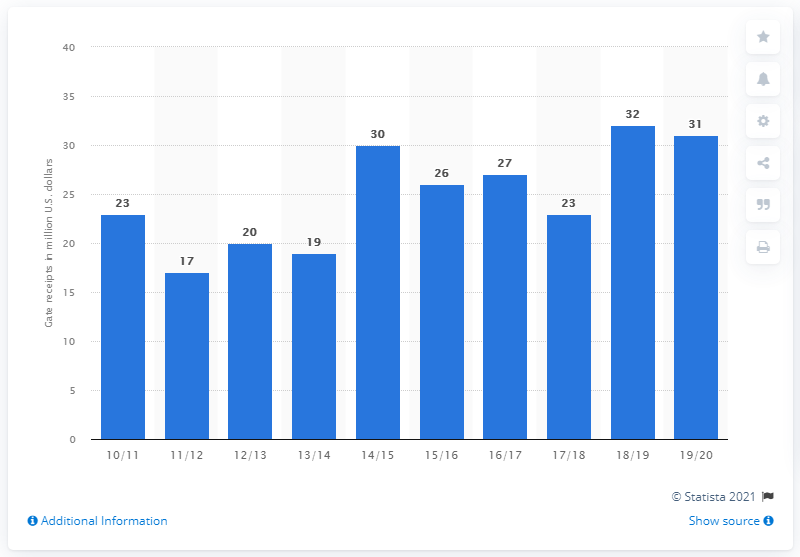List a handful of essential elements in this visual. The Atlanta Hawks' ticket sales for the 2019/2020 season were approximately $31 million. 